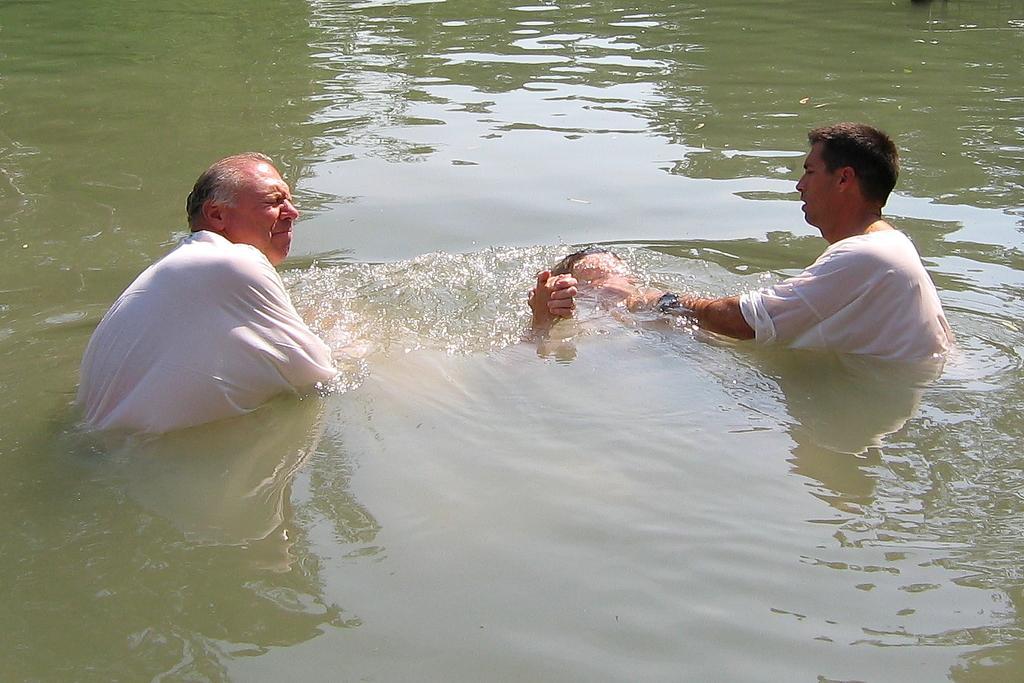How would you summarize this image in a sentence or two? In this image, we can see people inside the water. 